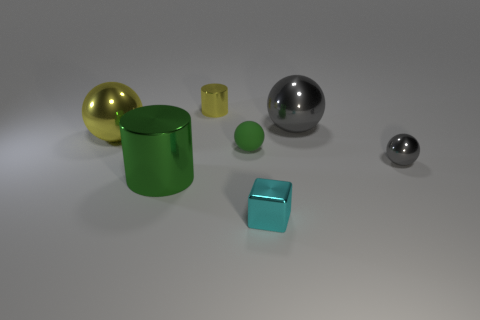Are the cyan thing and the large cylinder that is left of the large gray thing made of the same material?
Keep it short and to the point. Yes. What is the size of the ball that is the same color as the tiny cylinder?
Offer a terse response. Large. Are there any gray objects made of the same material as the big cylinder?
Offer a terse response. Yes. What number of objects are either big metal things behind the large yellow shiny thing or gray metallic balls in front of the tiny green thing?
Ensure brevity in your answer.  2. Does the green rubber object have the same shape as the small thing behind the small matte ball?
Offer a terse response. No. How many other things are the same shape as the tiny cyan thing?
Ensure brevity in your answer.  0. What number of things are small cyan things or tiny green cubes?
Provide a succinct answer. 1. Do the tiny matte object and the big cylinder have the same color?
Provide a succinct answer. Yes. Is there anything else that is the same size as the cyan object?
Your answer should be very brief. Yes. There is a yellow metallic thing that is behind the gray object that is left of the small gray metallic ball; what shape is it?
Keep it short and to the point. Cylinder. 